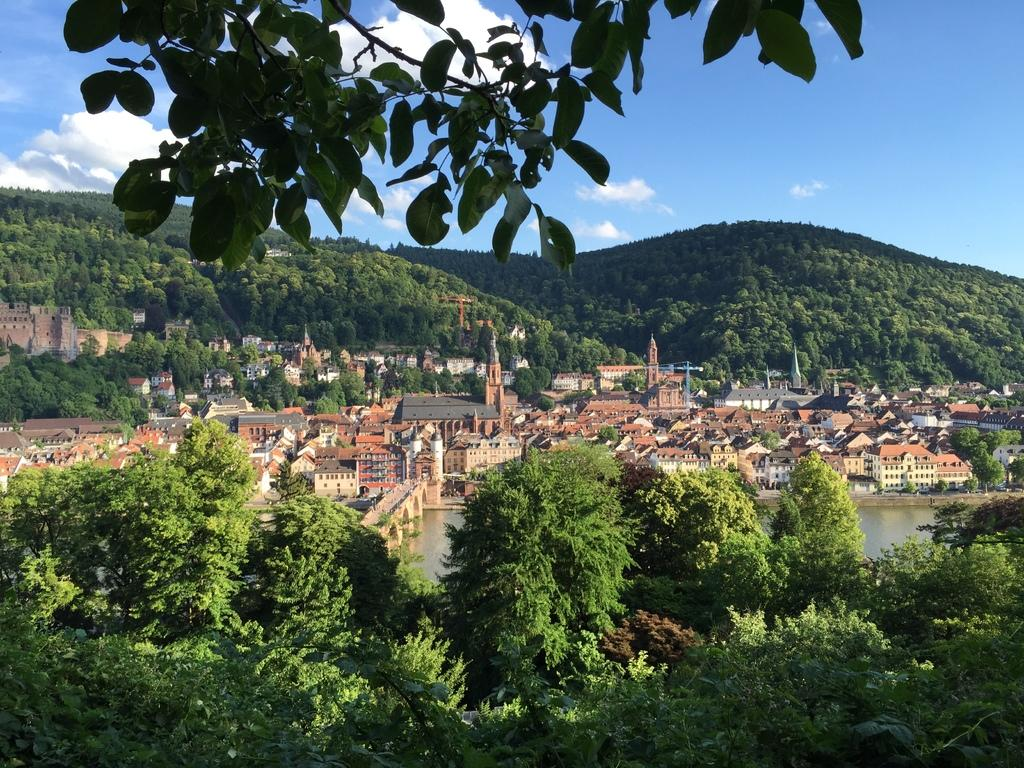What structures are located in the center of the image? There are buildings in the center of the image. What type of vegetation is at the bottom of the image? There are trees at the bottom of the image. What natural features can be seen in the background of the image? There are mountains in the background of the image. What is visible in the sky in the background of the image? The sky is visible in the background of the image. Can you tell me how many carpenters are working on the buildings in the image? There is no indication of carpenters or any construction work in the image; it simply shows buildings, trees, mountains, and the sky. What type of station is visible in the image? There is no station present in the image. 